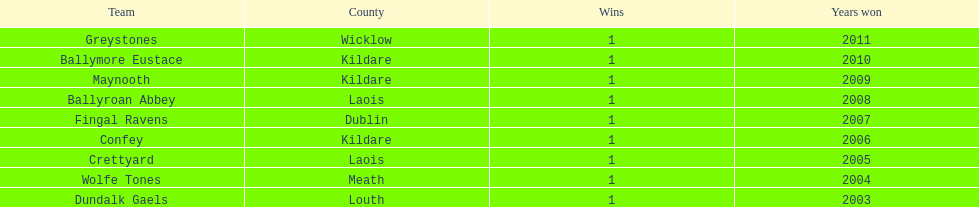In which years did each team achieve victory? 2011, 2010, 2009, 2008, 2007, 2006, 2005, 2004, 2003. 